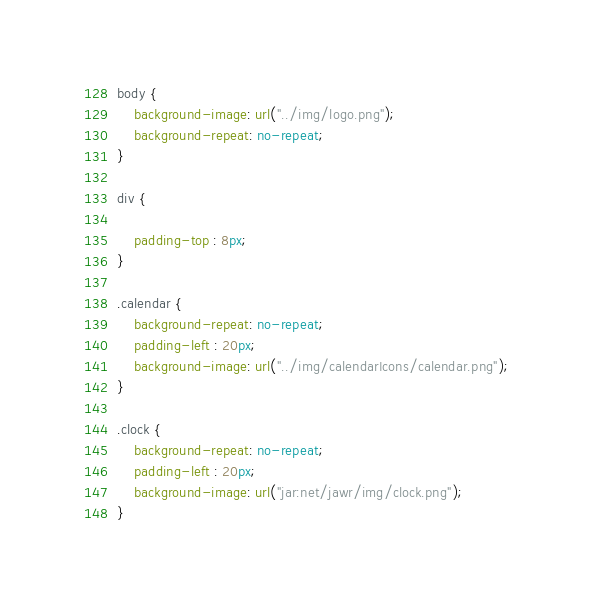Convert code to text. <code><loc_0><loc_0><loc_500><loc_500><_CSS_>body {
	background-image: url("../img/logo.png");
	background-repeat: no-repeat;
}

div {

	padding-top : 8px;		
}

.calendar {
	background-repeat: no-repeat;
	padding-left : 20px;
	background-image: url("../img/calendarIcons/calendar.png");
}

.clock {
	background-repeat: no-repeat;
	padding-left : 20px;
	background-image: url("jar:net/jawr/img/clock.png");
}</code> 